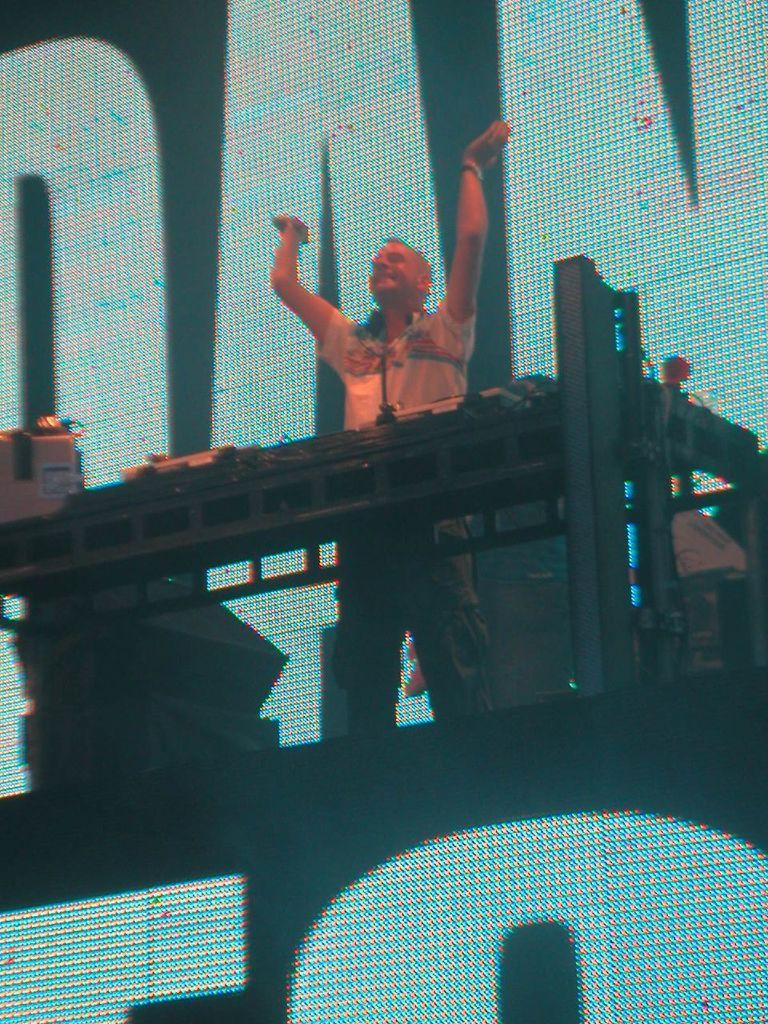What is the man doing in the image? The man is standing on a platform. What is in front of the man? There is a stand in front of the man. What can be seen on the stand? There are items on the stand. What is visible in the background? There is a screen and other objects visible in the background. How many boats are visible in the image? There are no boats visible in the image. What type of duck can be seen interacting with the man on the platform? There is no duck present in the image; the man is standing alone on the platform. 